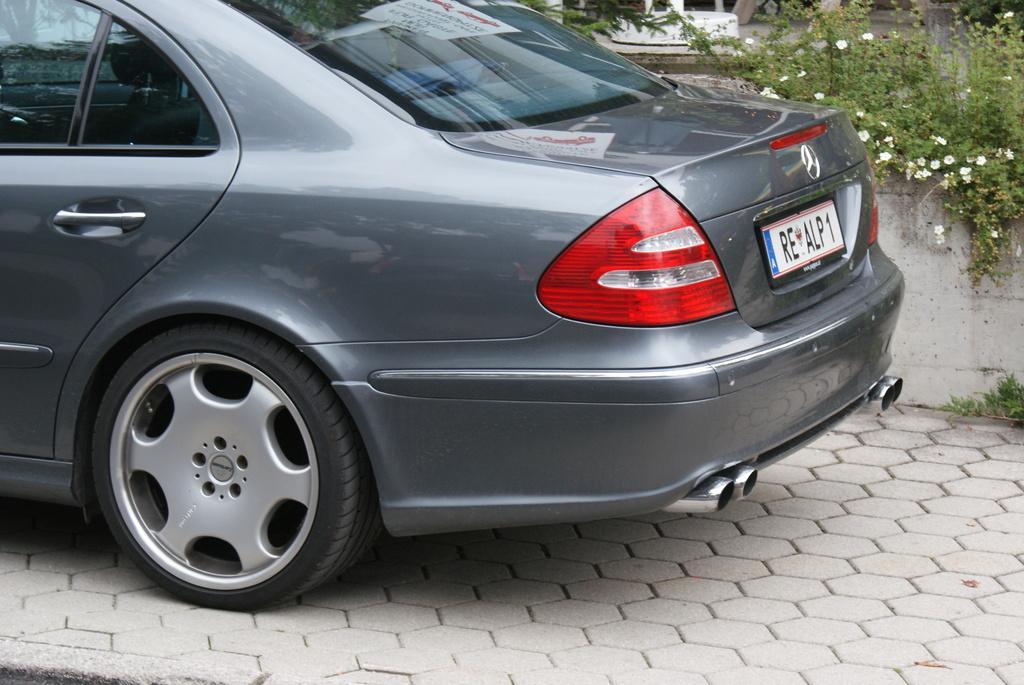Please provide a concise description of this image. In this image we can see a car with a number plate. On the right side there is a wall. Near to the wall there are flowers on the plants. On the ground there is a floor with bricks. 